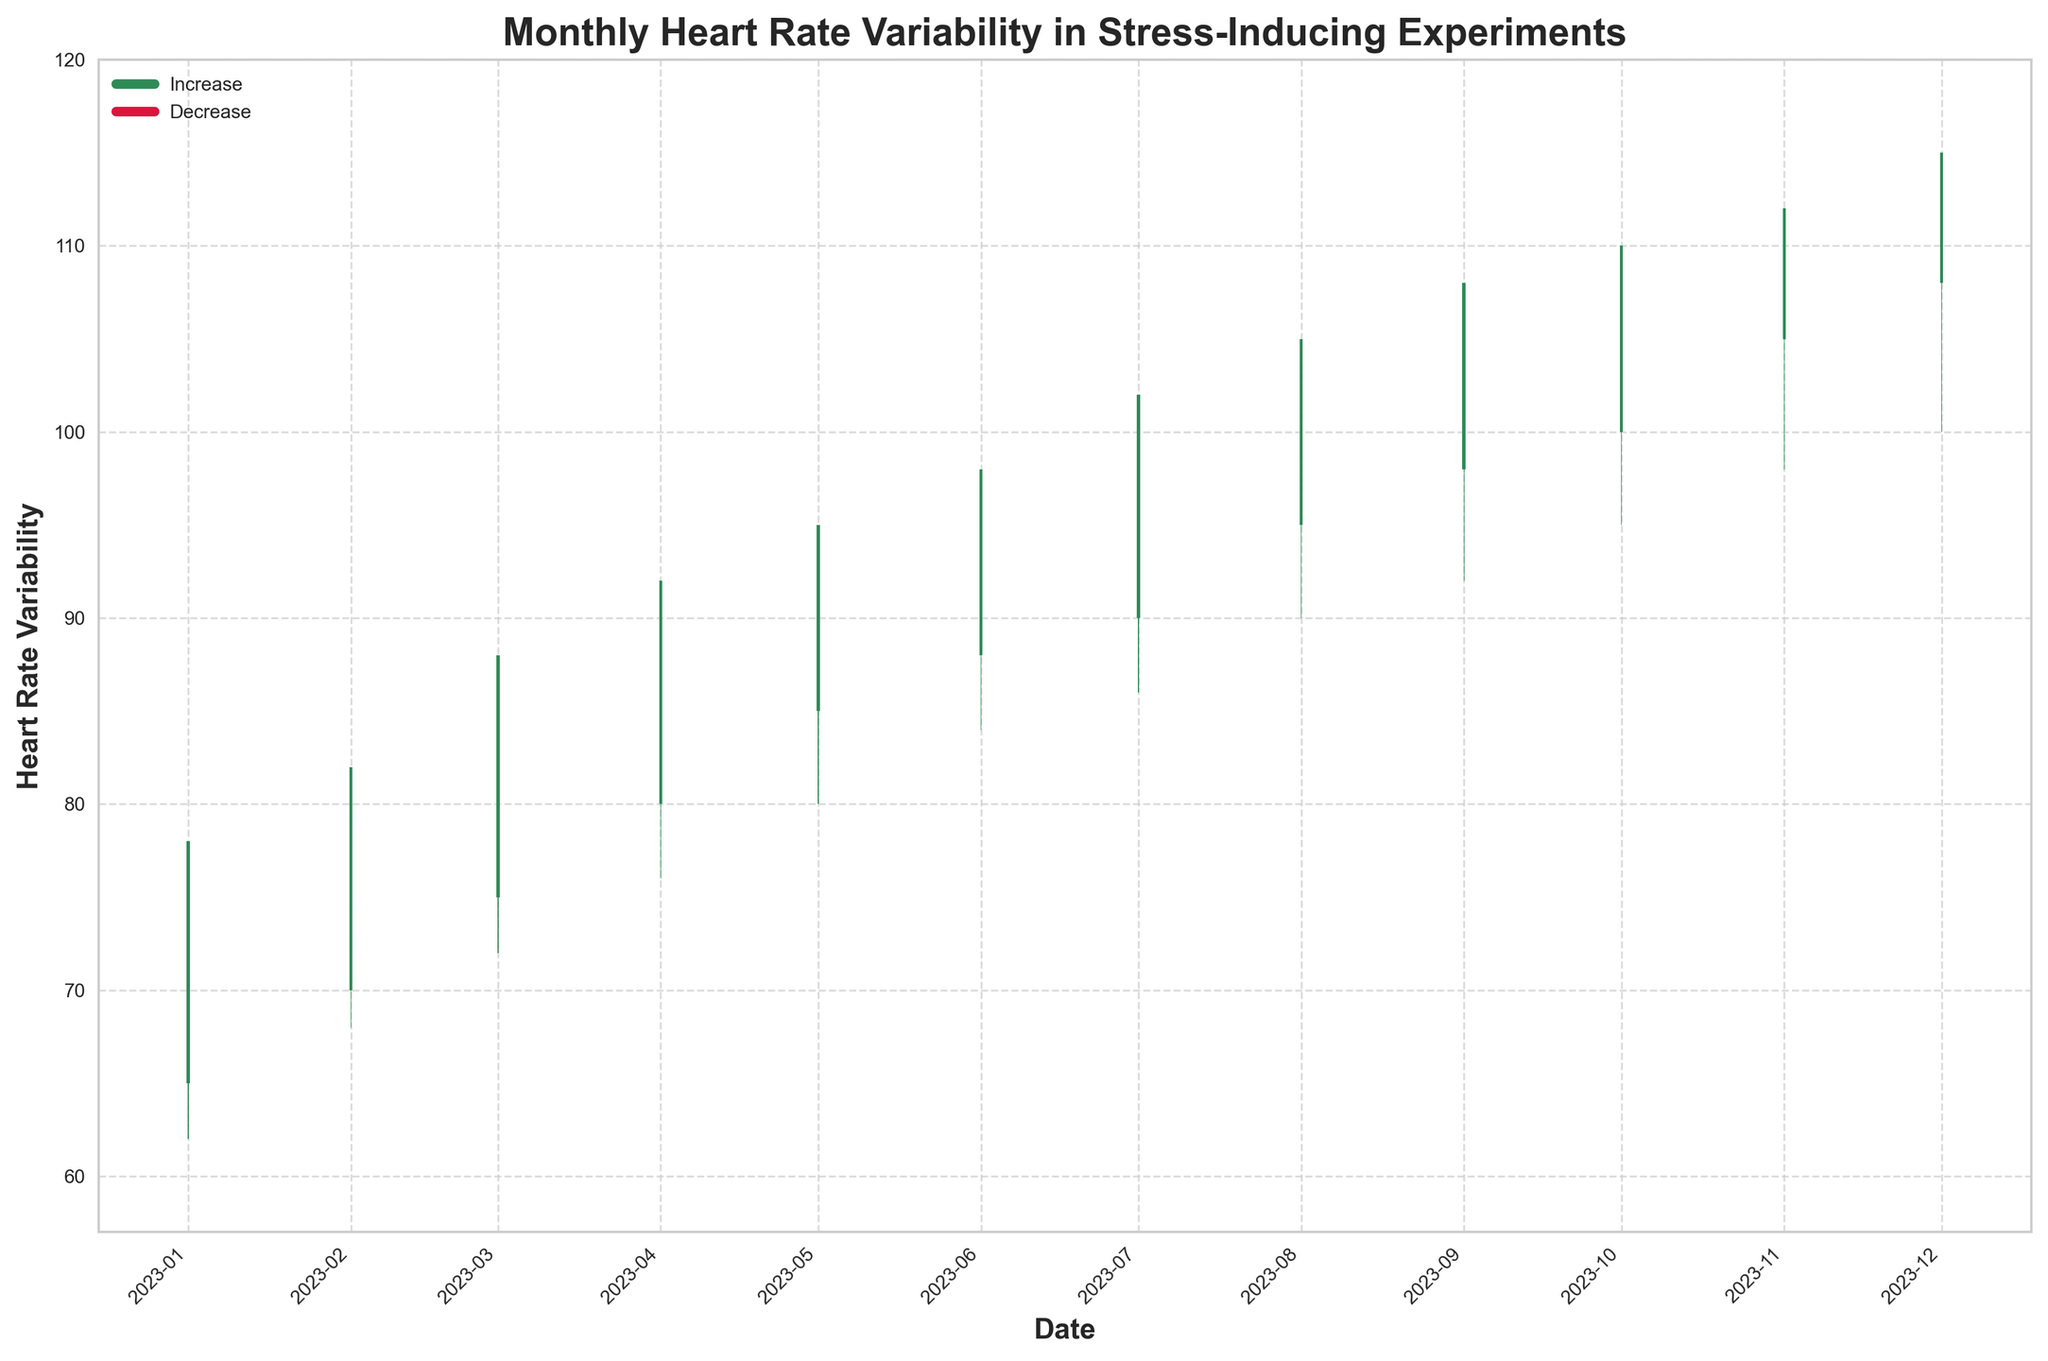What is the title of the figure? The title is typically located at the top of the figure in larger, bold font. Reading it directly gives us the name "Monthly Heart Rate Variability in Stress-Inducing Experiments."
Answer: Monthly Heart Rate Variability in Stress-Inducing Experiments What period does the x-axis cover? The x-axis shows dates formatted on a monthly basis. By looking at the first and last ticks, we can see the period spans from January 2023 to December 2023.
Answer: January 2023 to December 2023 How many months show an increase in heart rate variability from opening to closing? By identifying the bars colored in seagreen which indicate an increase from opening to closing, we count 12 bars. This is the number of months with increasing heart rate variability from the open to the close.
Answer: 12 months Which month had the highest recorded heart rate variability? To determine the highest value, we look at the highest point of the 'High' values in the chart. The bar for December shows the highest value of 115.
Answer: December 2023 What is the range of heart rate variability for July? The range is calculated by subtracting the 'Low' value from the 'High' value for July. The 'High' value is 102, and the 'Low' value is 86, so the range is 102 - 86 = 16.
Answer: 16 Which month had the smallest difference between the highest and lowest heart rate variability? Calculate the difference between 'High' and 'Low' for each month and compare them. The smallest difference is found in January with a 'High' of 78 and a 'Low' of 62, yielding a difference of 16.
Answer: January 2023 From which month to which month did the opening heart rate variability increase every consecutive month? Observe the 'Open' values for consecutive months. The values increase each month from 65 in January to 108 in December without any decrease.
Answer: January 2023 to December 2023 What is the median closing heart rate variability over the year? List out the 'Close' values for all 12 months: 70, 75, 80, 85, 88, 90, 95, 98, 100, 105, 108, and 110. The median is the average of the 6th and 7th values when sorted, which are 90 and 95. Thus, the median is (90 + 95) / 2 = 92.5.
Answer: 92.5 